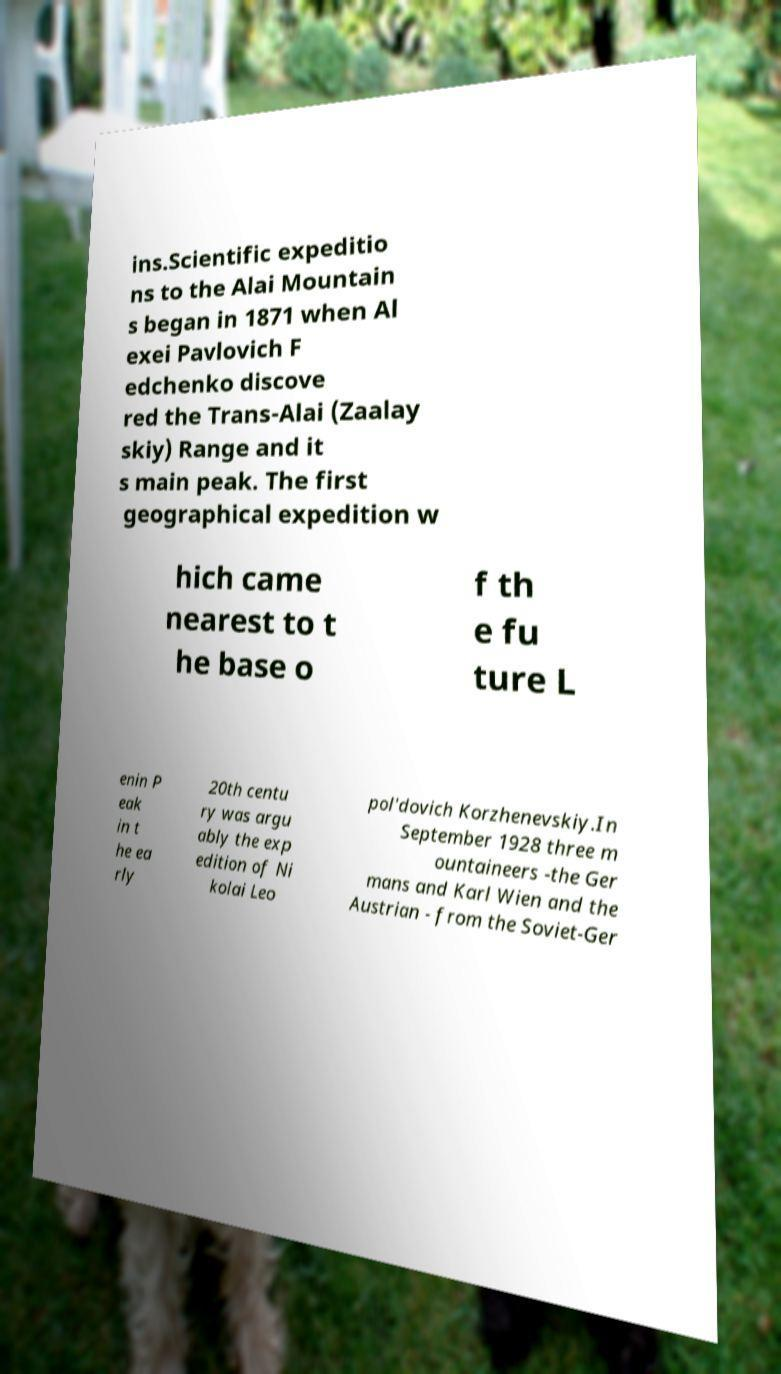Could you assist in decoding the text presented in this image and type it out clearly? ins.Scientific expeditio ns to the Alai Mountain s began in 1871 when Al exei Pavlovich F edchenko discove red the Trans-Alai (Zaalay skiy) Range and it s main peak. The first geographical expedition w hich came nearest to t he base o f th e fu ture L enin P eak in t he ea rly 20th centu ry was argu ably the exp edition of Ni kolai Leo pol'dovich Korzhenevskiy.In September 1928 three m ountaineers -the Ger mans and Karl Wien and the Austrian - from the Soviet-Ger 